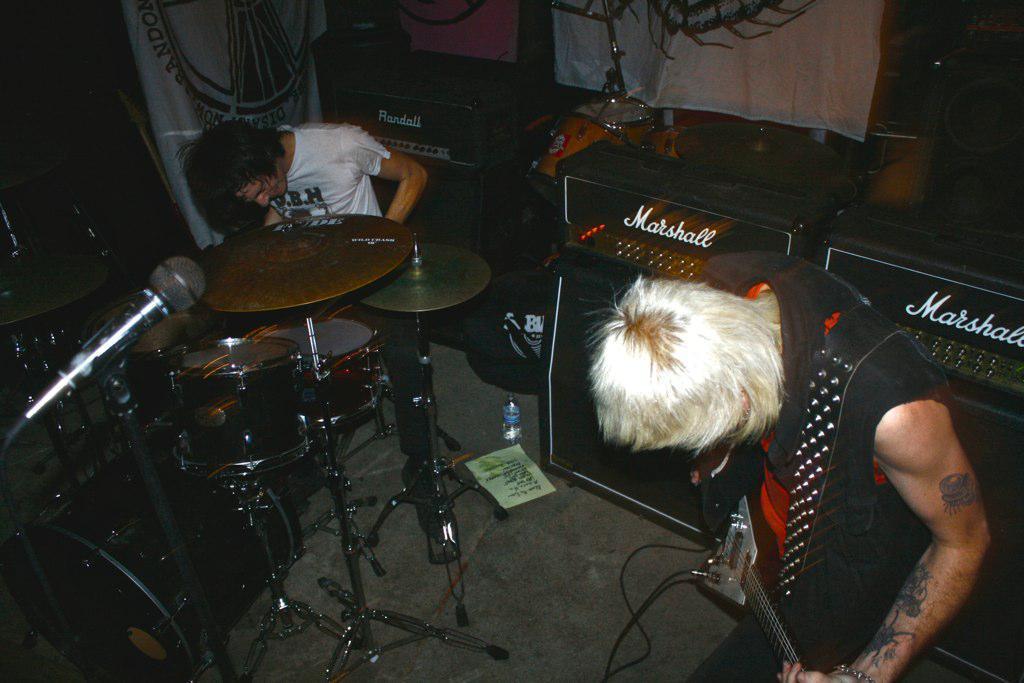Could you give a brief overview of what you see in this image? As we can see in the image there is a banner, two people over here. The man who is standing in the right is holding guitar and the man on the left side is playing musical drums. There is a mic over here. 